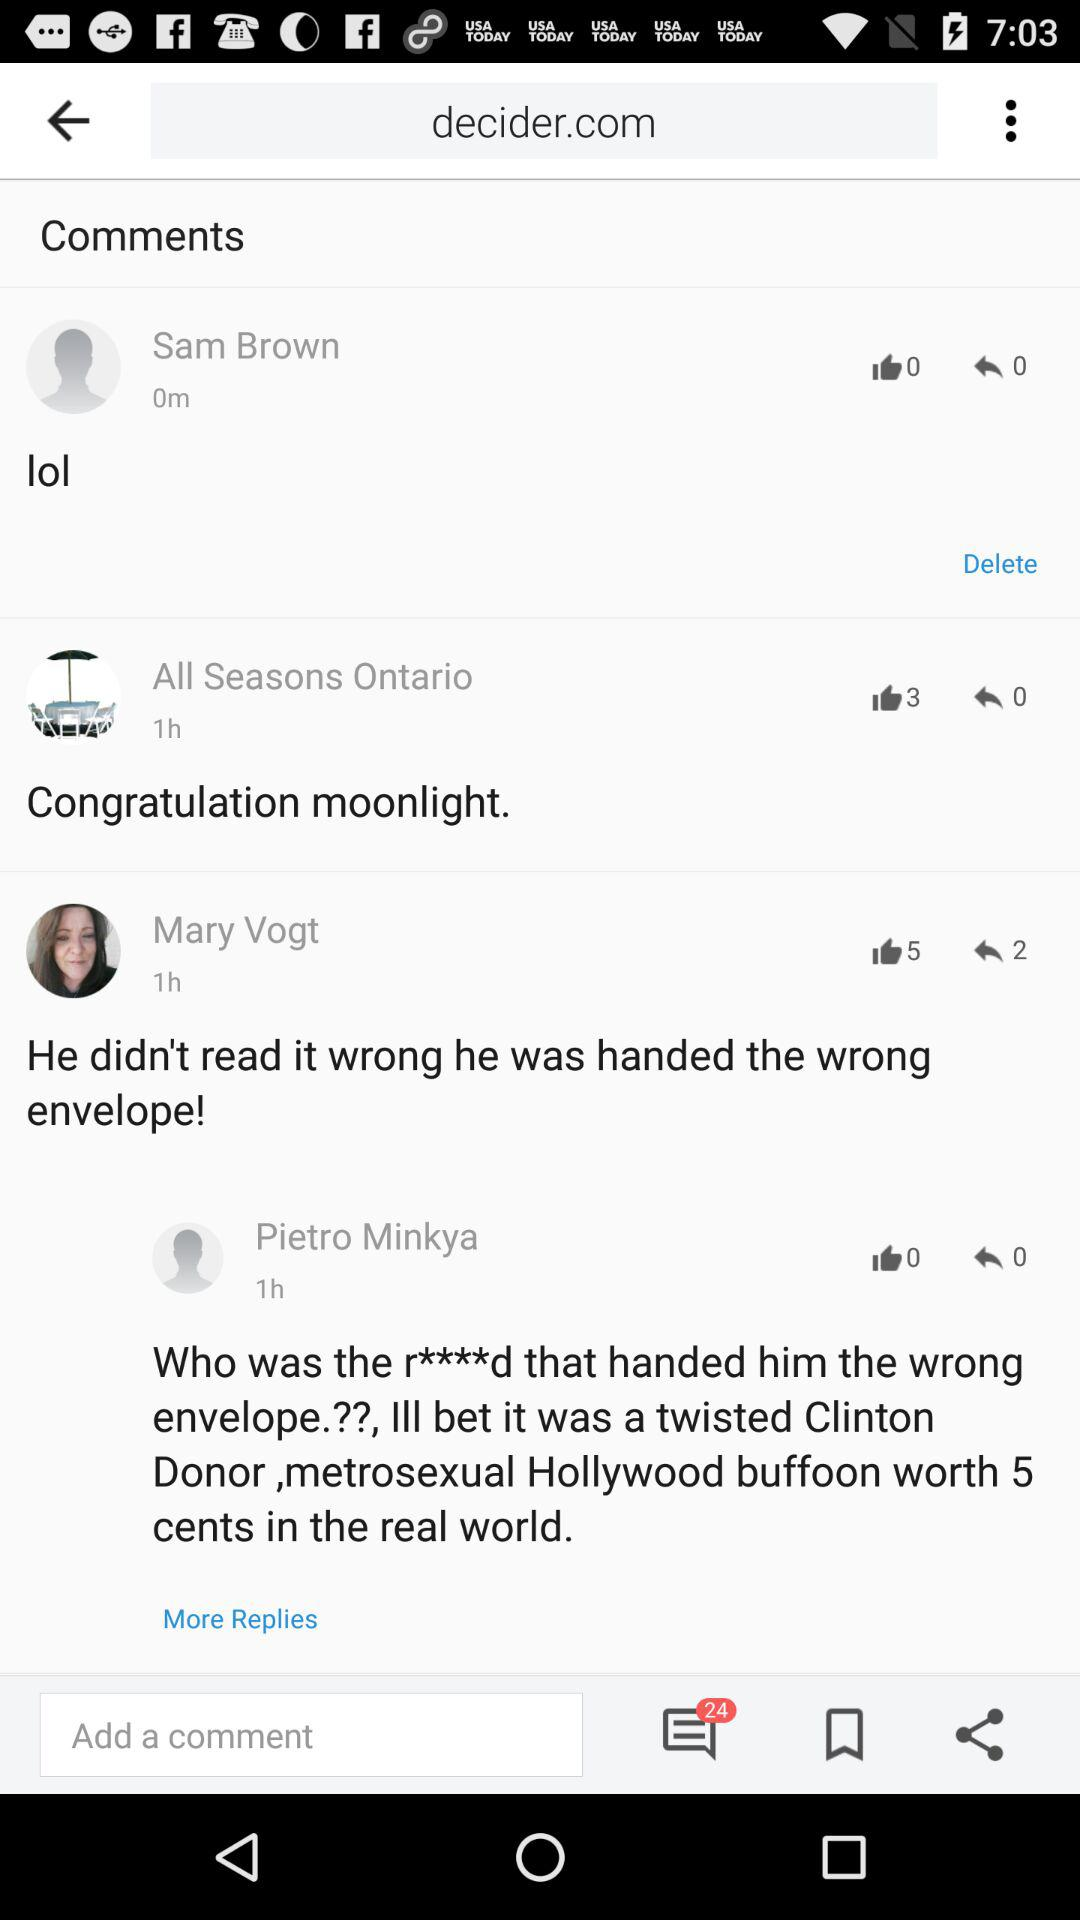How many comments have no thumbs up?
Answer the question using a single word or phrase. 2 